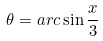<formula> <loc_0><loc_0><loc_500><loc_500>\theta = a r c \sin \frac { x } { 3 }</formula> 